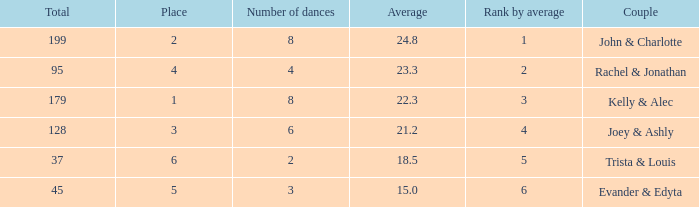What is the highest average that has 6 dances and a total of over 128? None. 